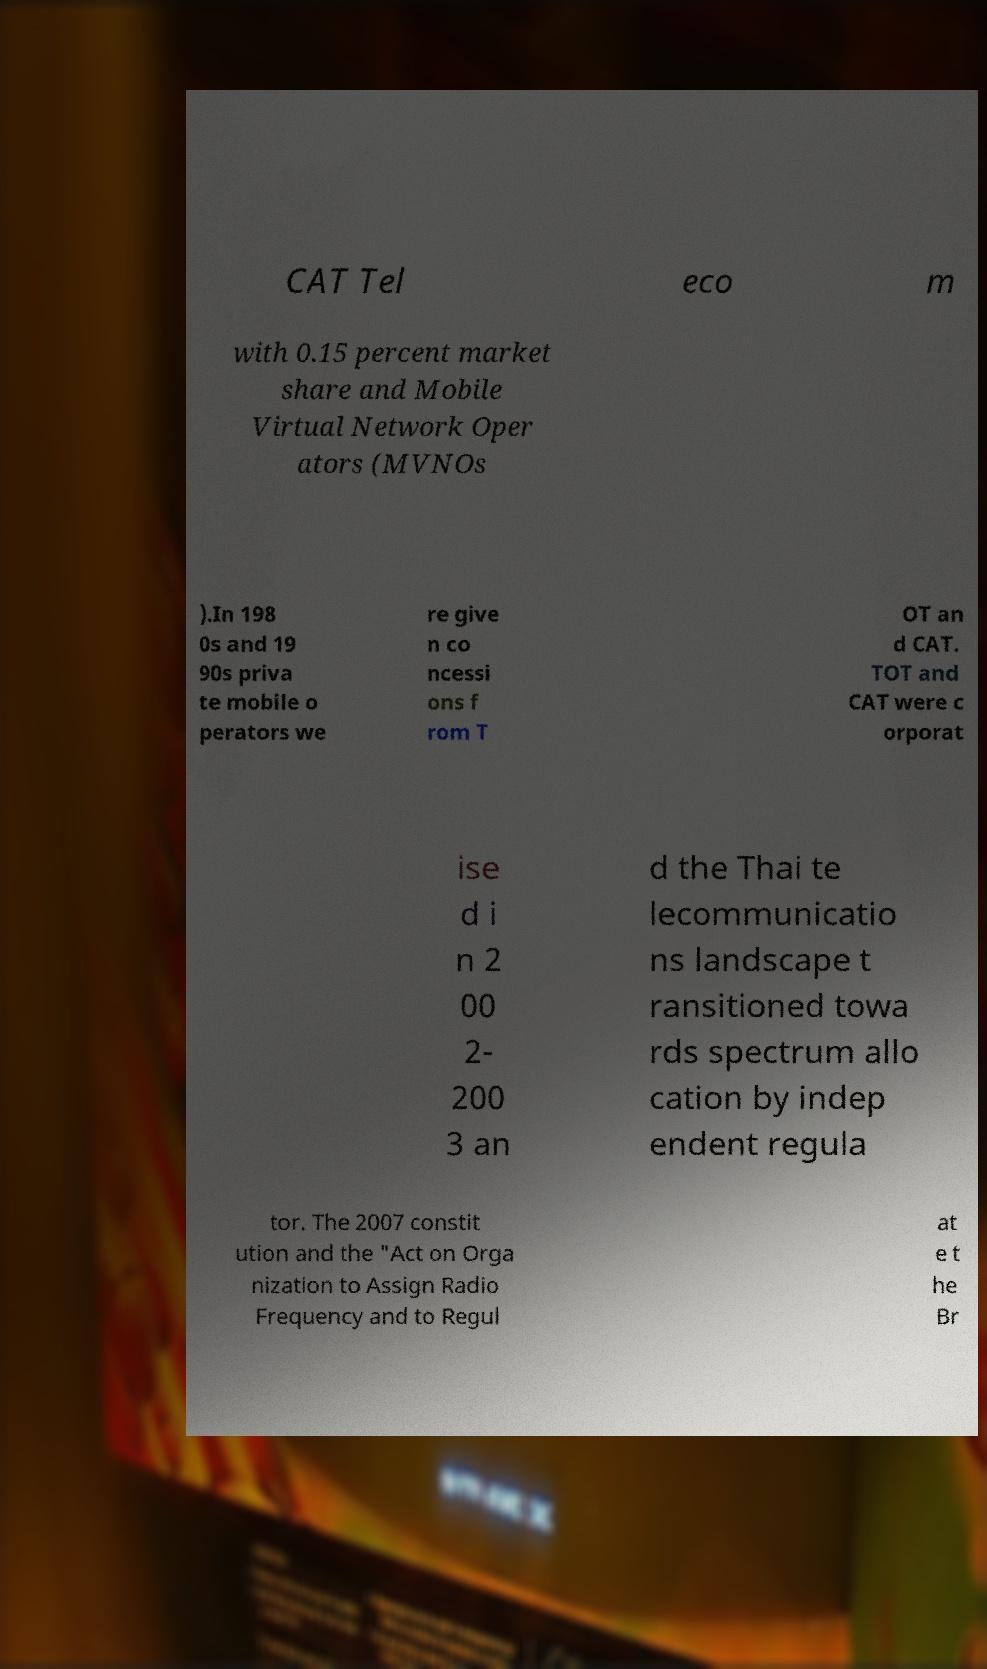Can you read and provide the text displayed in the image?This photo seems to have some interesting text. Can you extract and type it out for me? CAT Tel eco m with 0.15 percent market share and Mobile Virtual Network Oper ators (MVNOs ).In 198 0s and 19 90s priva te mobile o perators we re give n co ncessi ons f rom T OT an d CAT. TOT and CAT were c orporat ise d i n 2 00 2- 200 3 an d the Thai te lecommunicatio ns landscape t ransitioned towa rds spectrum allo cation by indep endent regula tor. The 2007 constit ution and the "Act on Orga nization to Assign Radio Frequency and to Regul at e t he Br 